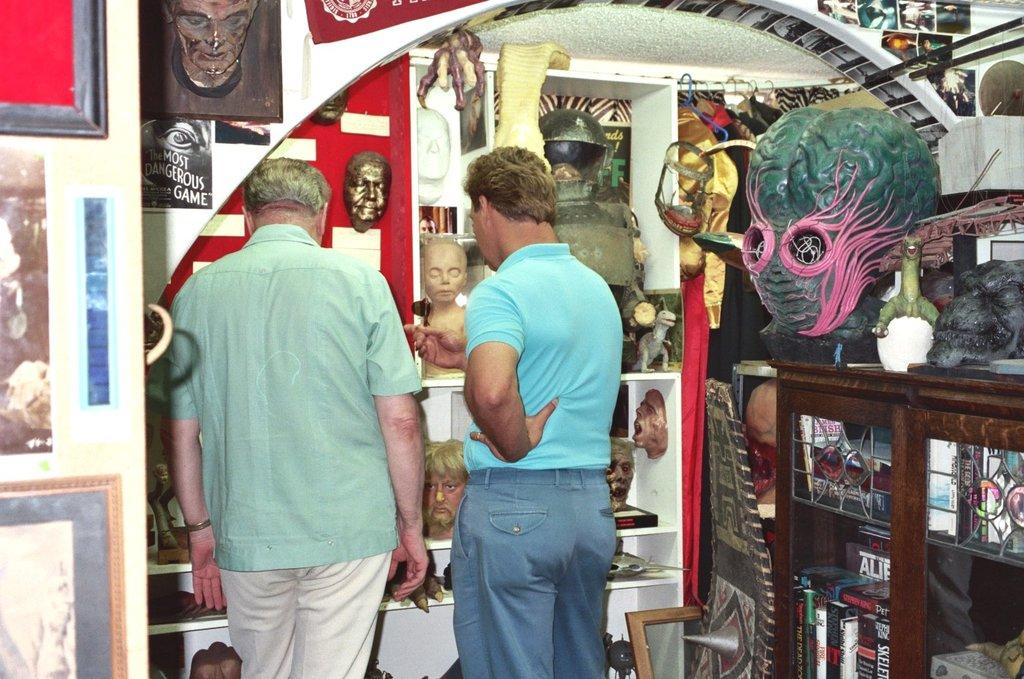How many people are in the image? There are two people in the image. What are the people doing in the image? The people are standing. What type of furniture is present in the image? There are shelves in the image. What can be seen on the walls in the image? There are frames on the walls in the image. What type of prison can be seen in the image? There is no prison present in the image. Can you tell me how many hospital beds are visible in the image? There are no hospital beds present in the image. 